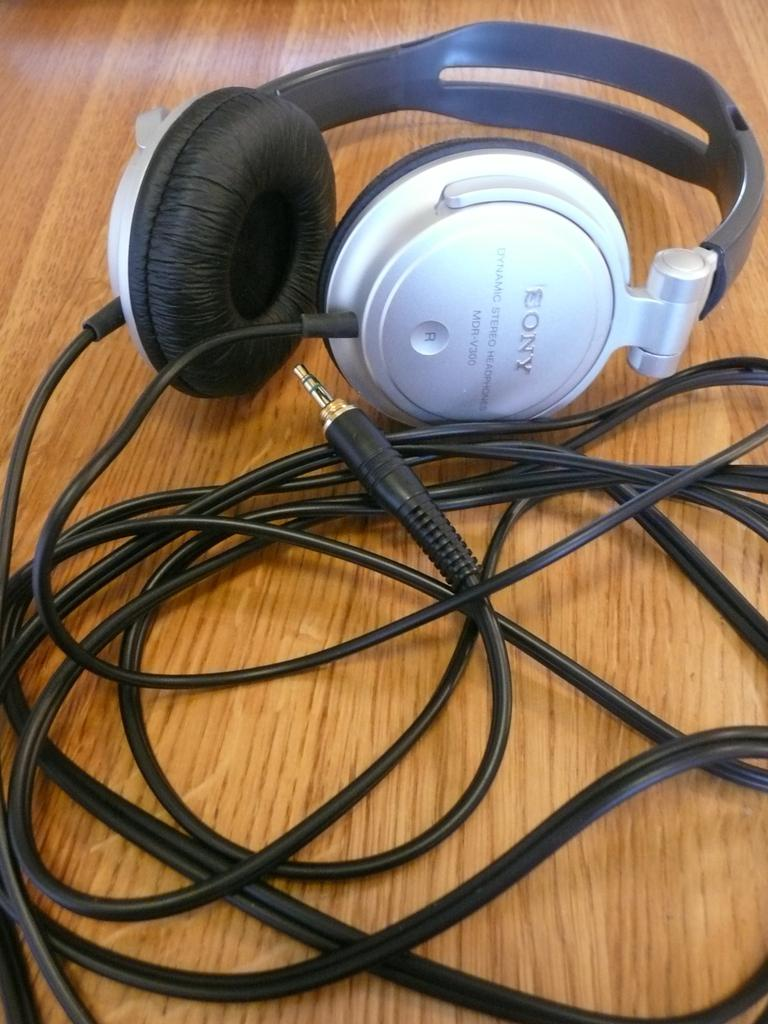What is the main object in the image? There is a headset in the image. What feature is present on the headset? The headset has wires attached to it. Where is the headset located? The headset is placed on a wooden table. Reasoning: Let'ing: Let's think step by step in order to produce the conversation. We start by identifying the main object in the image, which is the headset. Then, we describe a specific feature of the headset, which is the presence of wires. Finally, we mention the location of the headset, which is on a wooden table. Each question is designed to elicit a specific detail about the image that is known from the provided facts. Absurd Question/Answer: How many cattle are visible in the image? There are no cattle present in the image. What type of visitor can be seen interacting with the headset in the image? There is no visitor present in the image; only the headset and the wooden table are visible. 